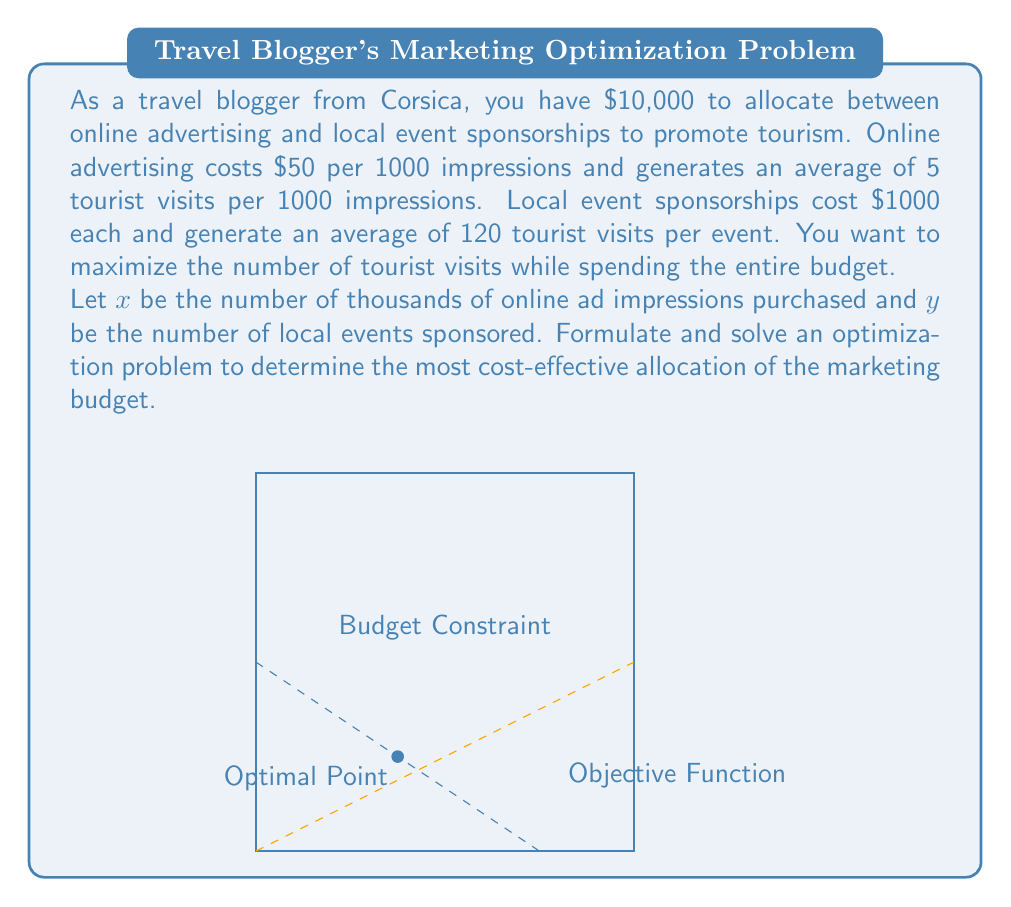Show me your answer to this math problem. Let's approach this step-by-step:

1) First, we need to set up our constraints:
   Budget constraint: $50x + 1000y = 10000$
   Non-negativity: $x \geq 0, y \geq 0$

2) Our objective function is to maximize the number of tourist visits:
   $Z = 5x + 120y$

3) We can rewrite the budget constraint as:
   $y = 10 - 0.05x$

4) Substituting this into our objective function:
   $Z = 5x + 120(10 - 0.05x) = 5x + 1200 - 6x = 1200 - x$

5) To maximize Z, we need to minimize x. However, we can't make x negative due to our non-negativity constraint.

6) The optimal solution occurs at the corner point where the budget line intersects the y-axis:
   When $x = 0$, $y = 10$

7) We can verify this by checking the other corner point:
   When $y = 0$, $x = 200$, which gives fewer visits (1000) than $x = 0, y = 10$ (1200)

8) Therefore, the optimal allocation is to spend the entire budget on local event sponsorships:
   $y = 10$ events, $x = 0$ thousand impressions

9) This will result in $120 * 10 = 1200$ tourist visits.
Answer: Sponsor 10 local events ($10,000), 0 online ads ($0) 